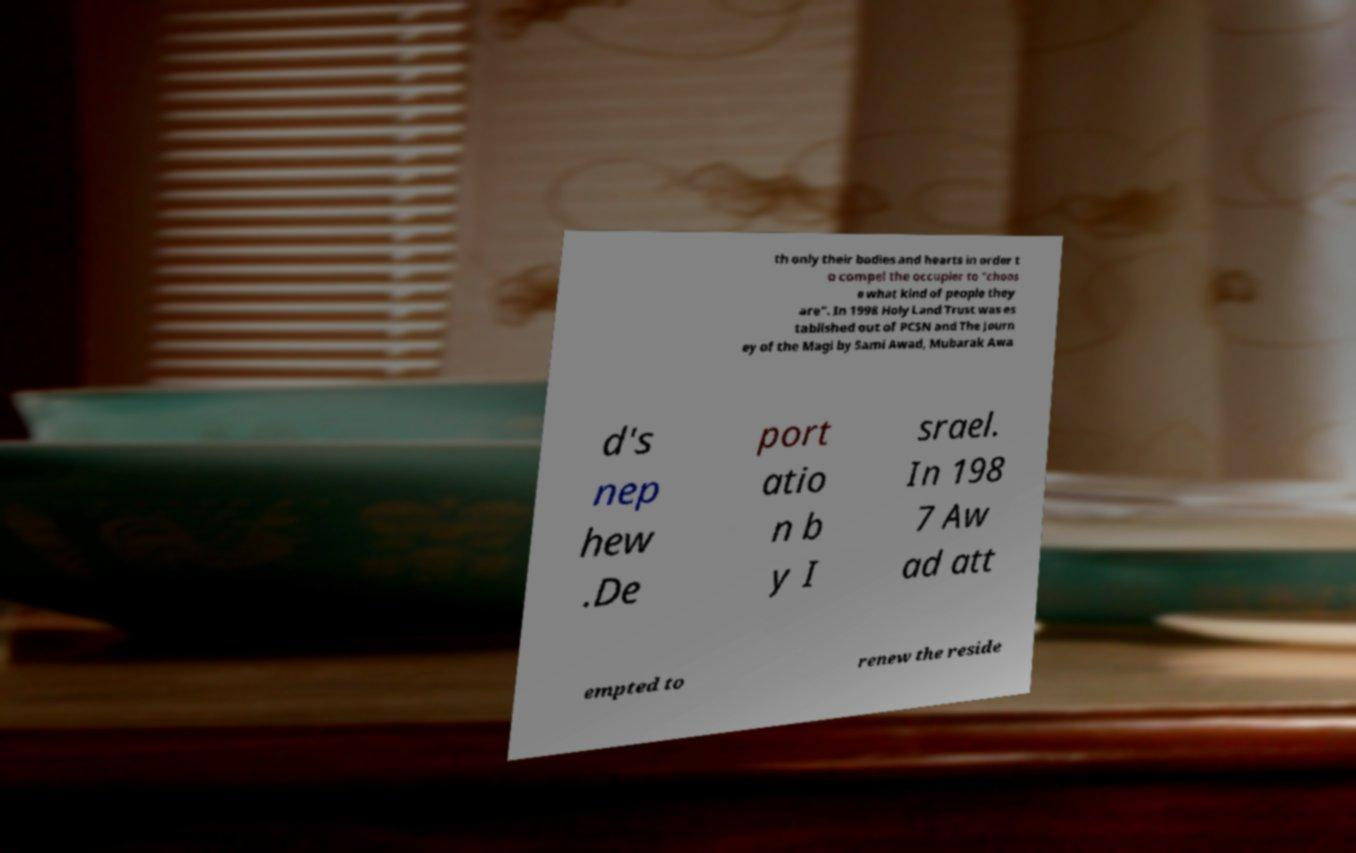Please identify and transcribe the text found in this image. th only their bodies and hearts in order t o compel the occupier to "choos e what kind of people they are". In 1998 Holy Land Trust was es tablished out of PCSN and The Journ ey of the Magi by Sami Awad, Mubarak Awa d's nep hew .De port atio n b y I srael. In 198 7 Aw ad att empted to renew the reside 